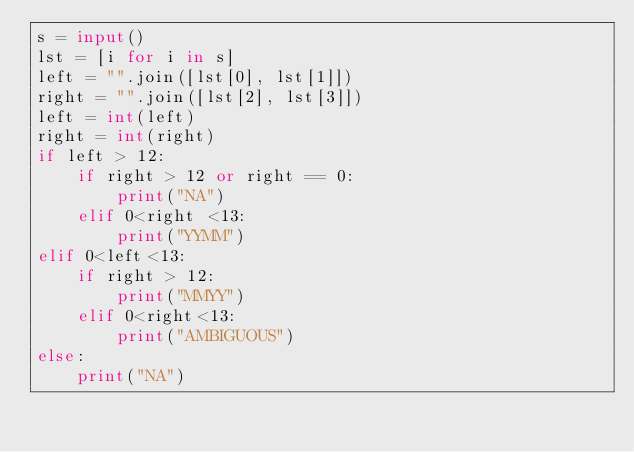<code> <loc_0><loc_0><loc_500><loc_500><_Python_>s = input()
lst = [i for i in s]
left = "".join([lst[0], lst[1]])
right = "".join([lst[2], lst[3]])
left = int(left)
right = int(right)
if left > 12:
    if right > 12 or right == 0:
        print("NA")
    elif 0<right <13:
        print("YYMM")
elif 0<left<13:
    if right > 12:
        print("MMYY")
    elif 0<right<13:
        print("AMBIGUOUS")
else:
    print("NA")</code> 